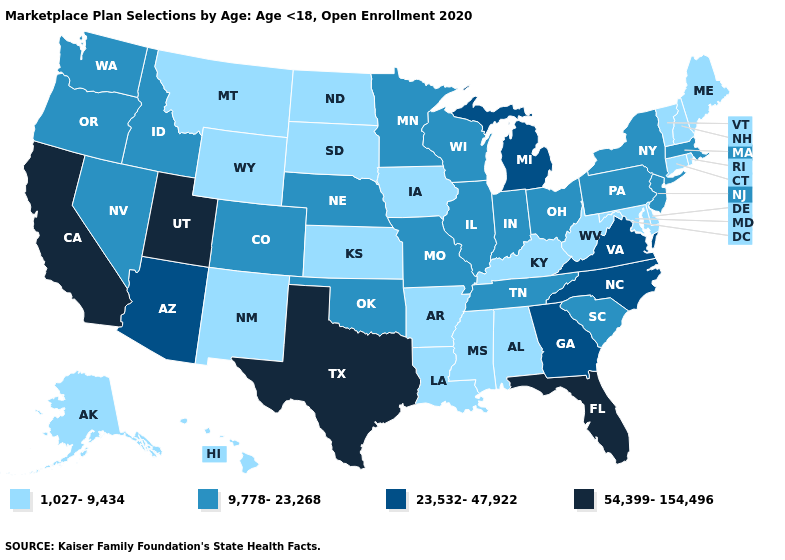Name the states that have a value in the range 54,399-154,496?
Give a very brief answer. California, Florida, Texas, Utah. What is the value of Missouri?
Write a very short answer. 9,778-23,268. Does South Dakota have the lowest value in the USA?
Write a very short answer. Yes. Name the states that have a value in the range 54,399-154,496?
Quick response, please. California, Florida, Texas, Utah. Does Texas have the highest value in the USA?
Give a very brief answer. Yes. What is the highest value in the West ?
Write a very short answer. 54,399-154,496. What is the value of Connecticut?
Answer briefly. 1,027-9,434. Does New York have a higher value than Illinois?
Keep it brief. No. Which states have the highest value in the USA?
Short answer required. California, Florida, Texas, Utah. What is the value of New Mexico?
Be succinct. 1,027-9,434. Name the states that have a value in the range 23,532-47,922?
Answer briefly. Arizona, Georgia, Michigan, North Carolina, Virginia. Which states have the lowest value in the Northeast?
Answer briefly. Connecticut, Maine, New Hampshire, Rhode Island, Vermont. Does Kansas have the same value as Maine?
Quick response, please. Yes. Does Massachusetts have the highest value in the Northeast?
Give a very brief answer. Yes. What is the value of Missouri?
Write a very short answer. 9,778-23,268. 